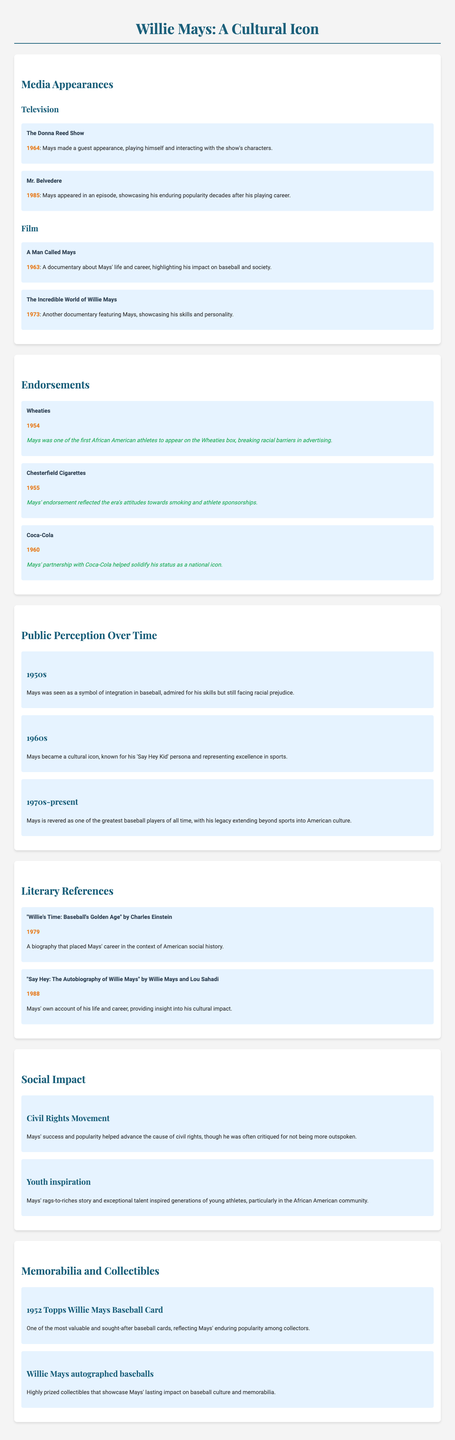What television show did Willie Mays appear in during 1964? The document lists Mays' appearance on "The Donna Reed Show" in 1964 under media appearances.
Answer: The Donna Reed Show What year did Willie Mays endorse Wheaties? The document indicates that Mays endorsed Wheaties in 1954, which is listed under endorsements.
Answer: 1954 In which decade did Mays become a cultural icon? The document states that Mays became a cultural icon in the 1960s under public perception.
Answer: 1960s What is the title of the documentary released in 1973 about Willie Mays? The document mentions "The Incredible World of Willie Mays" as a documentary released in 1973 under media appearances.
Answer: The Incredible World of Willie Mays How did Willie Mays impact the Civil Rights Movement according to the document? The document notes that Mays' success and popularity helped advance the cause of civil rights, highlighting his social impact.
Answer: Helped advance the cause of civil rights What significance does the 1952 Topps Willie Mays Baseball Card hold? The document describes it as one of the most valuable and sought-after baseball cards, reflecting Mays' popularity among collectors.
Answer: Valuable and sought-after What was the reaction to Willie Mays during the 1950s regarding racial issues? The document states that Mays was seen as a symbol of integration in baseball despite facing racial prejudice in the 1950s.
Answer: Symbol of integration Who authored the autobiography of Willie Mays published in 1988? The document lists "Say Hey: The Autobiography of Willie Mays" by Willie Mays and Lou Sahadi published in 1988.
Answer: Willie Mays and Lou Sahadi 